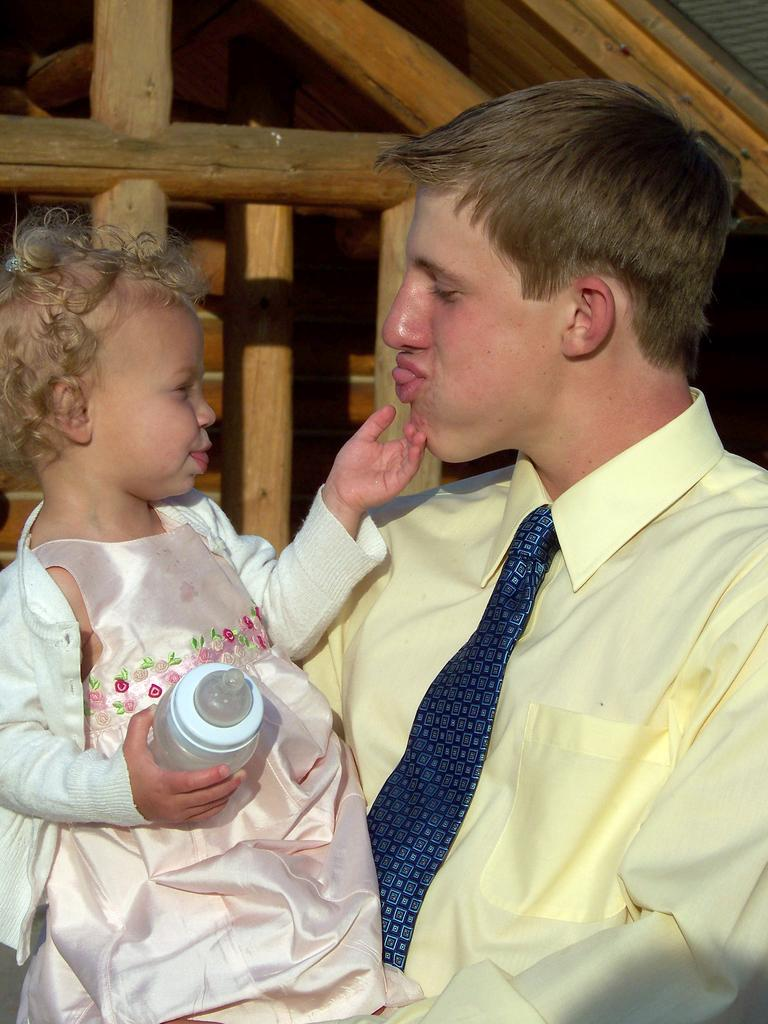What is the man in the image holding? The man is holding a baby in the image. What is the baby holding? The baby is holding a bottle. What can be seen in the background of the image? There are wooden frames visible in the background of the image. What type of sticks can be seen in the image? There are no sticks present in the image. What is the cause of the fear in the image? There is no fear depicted in the image; it features a man holding a baby who is holding a bottle. 